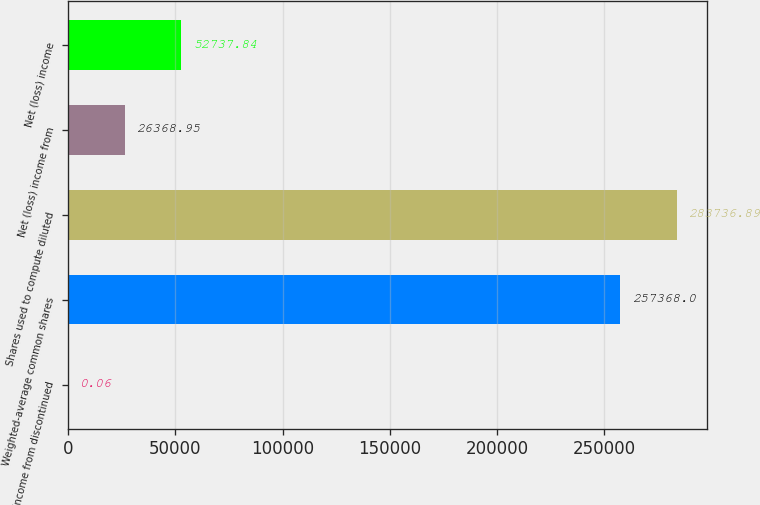<chart> <loc_0><loc_0><loc_500><loc_500><bar_chart><fcel>Net income from discontinued<fcel>Weighted-average common shares<fcel>Shares used to compute diluted<fcel>Net (loss) income from<fcel>Net (loss) income<nl><fcel>0.06<fcel>257368<fcel>283737<fcel>26369<fcel>52737.8<nl></chart> 